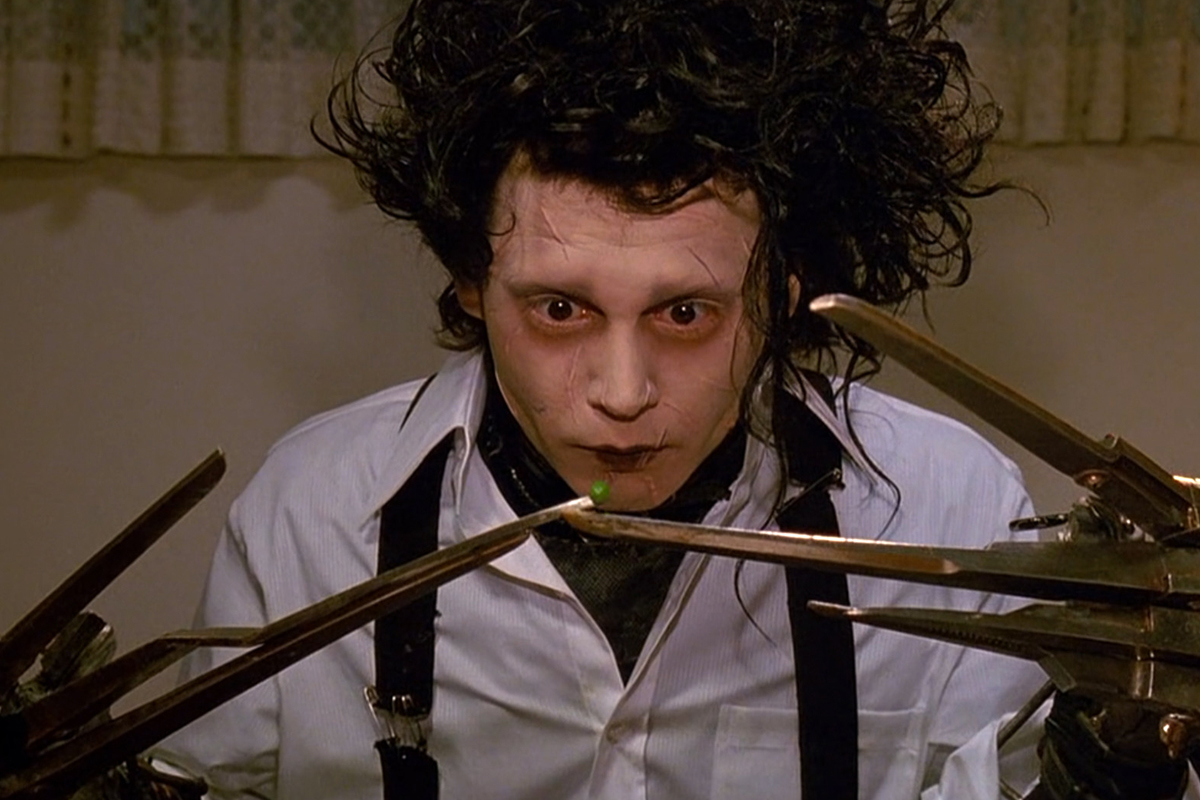Imagine what Edward might be thinking in this moment. Can you describe his thoughts? Edward might be thinking about the simplicity and complexity of human interactions and how he wishes he could experience them without the burden of his scissor hands. He could be contemplating the fragility of his situation, where even the smallest object, like the green pea, requires immense precision and caution. His thoughts might also drift to his sense of solitude and the desire for acceptance and understanding in a world he finds so difficult to navigate. 